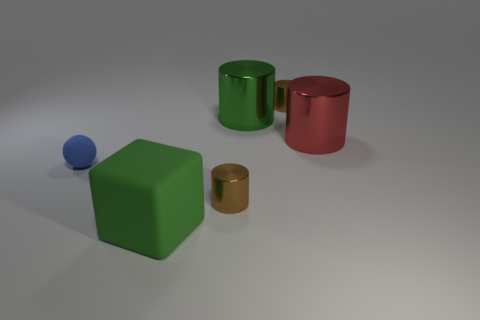Subtract all large green cylinders. How many cylinders are left? 3 Add 3 brown objects. How many objects exist? 9 Subtract all yellow cylinders. Subtract all red cubes. How many cylinders are left? 4 Subtract all spheres. How many objects are left? 5 Subtract all brown cylinders. Subtract all small blue rubber balls. How many objects are left? 3 Add 3 metallic objects. How many metallic objects are left? 7 Add 6 cyan matte balls. How many cyan matte balls exist? 6 Subtract 0 yellow balls. How many objects are left? 6 